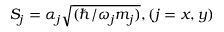<formula> <loc_0><loc_0><loc_500><loc_500>S _ { j } = \mathcal { \alpha } _ { j } \sqrt { ( \hbar { / } \omega _ { j } m _ { j } ) } , ( j = x , y )</formula> 